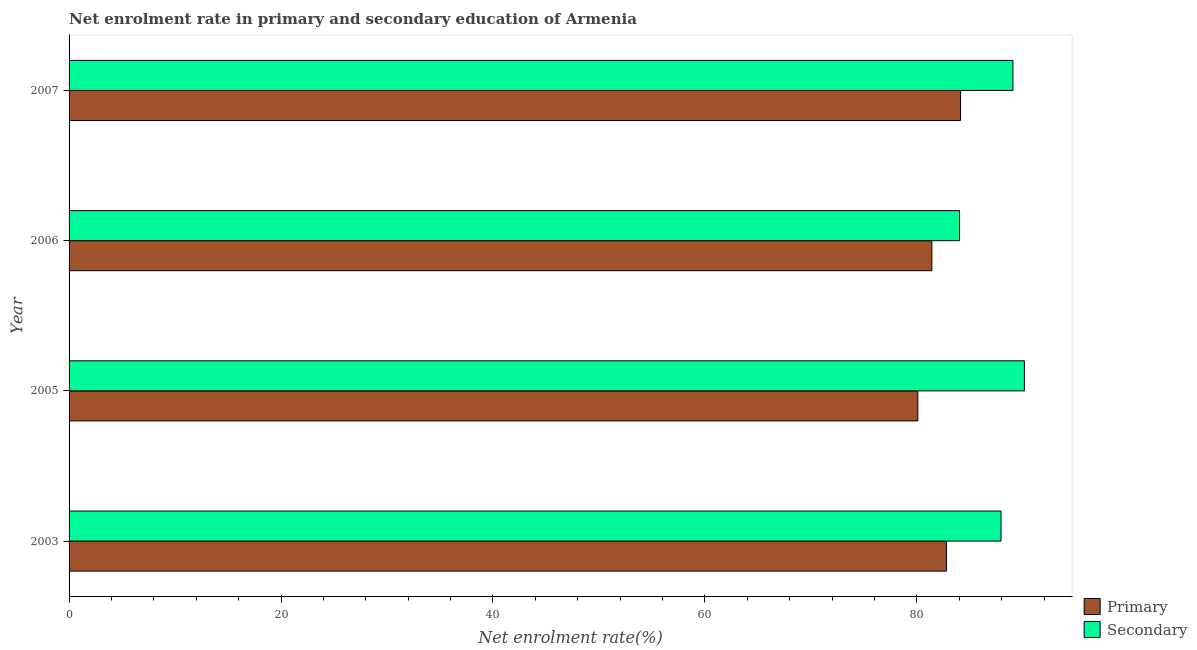How many different coloured bars are there?
Make the answer very short. 2. How many groups of bars are there?
Provide a short and direct response. 4. Are the number of bars per tick equal to the number of legend labels?
Your response must be concise. Yes. How many bars are there on the 4th tick from the top?
Give a very brief answer. 2. What is the enrollment rate in secondary education in 2005?
Your answer should be very brief. 90.14. Across all years, what is the maximum enrollment rate in primary education?
Your answer should be compact. 84.12. Across all years, what is the minimum enrollment rate in primary education?
Ensure brevity in your answer.  80.09. In which year was the enrollment rate in primary education maximum?
Make the answer very short. 2007. In which year was the enrollment rate in primary education minimum?
Offer a very short reply. 2005. What is the total enrollment rate in secondary education in the graph?
Offer a very short reply. 351.17. What is the difference between the enrollment rate in primary education in 2003 and that in 2006?
Make the answer very short. 1.38. What is the difference between the enrollment rate in primary education in 2006 and the enrollment rate in secondary education in 2007?
Provide a succinct answer. -7.65. What is the average enrollment rate in secondary education per year?
Your response must be concise. 87.79. In the year 2007, what is the difference between the enrollment rate in primary education and enrollment rate in secondary education?
Make the answer very short. -4.94. What is the ratio of the enrollment rate in secondary education in 2005 to that in 2007?
Offer a terse response. 1.01. Is the enrollment rate in secondary education in 2005 less than that in 2007?
Provide a short and direct response. No. What is the difference between the highest and the second highest enrollment rate in secondary education?
Your answer should be very brief. 1.08. What is the difference between the highest and the lowest enrollment rate in secondary education?
Your answer should be very brief. 6.12. Is the sum of the enrollment rate in secondary education in 2003 and 2005 greater than the maximum enrollment rate in primary education across all years?
Provide a succinct answer. Yes. What does the 1st bar from the top in 2007 represents?
Keep it short and to the point. Secondary. What does the 1st bar from the bottom in 2003 represents?
Offer a terse response. Primary. Are all the bars in the graph horizontal?
Provide a succinct answer. Yes. How many years are there in the graph?
Offer a very short reply. 4. What is the difference between two consecutive major ticks on the X-axis?
Give a very brief answer. 20. Are the values on the major ticks of X-axis written in scientific E-notation?
Your response must be concise. No. Does the graph contain grids?
Offer a very short reply. No. How many legend labels are there?
Your answer should be compact. 2. What is the title of the graph?
Ensure brevity in your answer.  Net enrolment rate in primary and secondary education of Armenia. Does "Nitrous oxide" appear as one of the legend labels in the graph?
Give a very brief answer. No. What is the label or title of the X-axis?
Your answer should be compact. Net enrolment rate(%). What is the Net enrolment rate(%) in Primary in 2003?
Keep it short and to the point. 82.79. What is the Net enrolment rate(%) in Secondary in 2003?
Provide a short and direct response. 87.94. What is the Net enrolment rate(%) in Primary in 2005?
Your answer should be very brief. 80.09. What is the Net enrolment rate(%) of Secondary in 2005?
Ensure brevity in your answer.  90.14. What is the Net enrolment rate(%) of Primary in 2006?
Your answer should be very brief. 81.41. What is the Net enrolment rate(%) of Secondary in 2006?
Offer a very short reply. 84.03. What is the Net enrolment rate(%) of Primary in 2007?
Your answer should be very brief. 84.12. What is the Net enrolment rate(%) in Secondary in 2007?
Provide a succinct answer. 89.06. Across all years, what is the maximum Net enrolment rate(%) in Primary?
Your answer should be very brief. 84.12. Across all years, what is the maximum Net enrolment rate(%) in Secondary?
Keep it short and to the point. 90.14. Across all years, what is the minimum Net enrolment rate(%) in Primary?
Your answer should be very brief. 80.09. Across all years, what is the minimum Net enrolment rate(%) of Secondary?
Your response must be concise. 84.03. What is the total Net enrolment rate(%) of Primary in the graph?
Your response must be concise. 328.41. What is the total Net enrolment rate(%) of Secondary in the graph?
Make the answer very short. 351.17. What is the difference between the Net enrolment rate(%) in Primary in 2003 and that in 2005?
Give a very brief answer. 2.7. What is the difference between the Net enrolment rate(%) in Secondary in 2003 and that in 2005?
Provide a short and direct response. -2.2. What is the difference between the Net enrolment rate(%) of Primary in 2003 and that in 2006?
Your answer should be very brief. 1.38. What is the difference between the Net enrolment rate(%) of Secondary in 2003 and that in 2006?
Your answer should be compact. 3.91. What is the difference between the Net enrolment rate(%) in Primary in 2003 and that in 2007?
Make the answer very short. -1.33. What is the difference between the Net enrolment rate(%) of Secondary in 2003 and that in 2007?
Your answer should be very brief. -1.12. What is the difference between the Net enrolment rate(%) in Primary in 2005 and that in 2006?
Your answer should be compact. -1.33. What is the difference between the Net enrolment rate(%) of Secondary in 2005 and that in 2006?
Your answer should be compact. 6.12. What is the difference between the Net enrolment rate(%) in Primary in 2005 and that in 2007?
Offer a very short reply. -4.03. What is the difference between the Net enrolment rate(%) in Secondary in 2005 and that in 2007?
Your response must be concise. 1.08. What is the difference between the Net enrolment rate(%) in Primary in 2006 and that in 2007?
Your response must be concise. -2.71. What is the difference between the Net enrolment rate(%) of Secondary in 2006 and that in 2007?
Your response must be concise. -5.04. What is the difference between the Net enrolment rate(%) of Primary in 2003 and the Net enrolment rate(%) of Secondary in 2005?
Your answer should be compact. -7.35. What is the difference between the Net enrolment rate(%) of Primary in 2003 and the Net enrolment rate(%) of Secondary in 2006?
Keep it short and to the point. -1.23. What is the difference between the Net enrolment rate(%) of Primary in 2003 and the Net enrolment rate(%) of Secondary in 2007?
Ensure brevity in your answer.  -6.27. What is the difference between the Net enrolment rate(%) in Primary in 2005 and the Net enrolment rate(%) in Secondary in 2006?
Give a very brief answer. -3.94. What is the difference between the Net enrolment rate(%) in Primary in 2005 and the Net enrolment rate(%) in Secondary in 2007?
Keep it short and to the point. -8.97. What is the difference between the Net enrolment rate(%) of Primary in 2006 and the Net enrolment rate(%) of Secondary in 2007?
Your answer should be very brief. -7.65. What is the average Net enrolment rate(%) in Primary per year?
Your answer should be very brief. 82.1. What is the average Net enrolment rate(%) of Secondary per year?
Provide a short and direct response. 87.79. In the year 2003, what is the difference between the Net enrolment rate(%) in Primary and Net enrolment rate(%) in Secondary?
Offer a very short reply. -5.15. In the year 2005, what is the difference between the Net enrolment rate(%) in Primary and Net enrolment rate(%) in Secondary?
Keep it short and to the point. -10.05. In the year 2006, what is the difference between the Net enrolment rate(%) in Primary and Net enrolment rate(%) in Secondary?
Offer a terse response. -2.61. In the year 2007, what is the difference between the Net enrolment rate(%) of Primary and Net enrolment rate(%) of Secondary?
Keep it short and to the point. -4.94. What is the ratio of the Net enrolment rate(%) of Primary in 2003 to that in 2005?
Give a very brief answer. 1.03. What is the ratio of the Net enrolment rate(%) in Secondary in 2003 to that in 2005?
Offer a very short reply. 0.98. What is the ratio of the Net enrolment rate(%) in Primary in 2003 to that in 2006?
Offer a very short reply. 1.02. What is the ratio of the Net enrolment rate(%) in Secondary in 2003 to that in 2006?
Your answer should be very brief. 1.05. What is the ratio of the Net enrolment rate(%) in Primary in 2003 to that in 2007?
Your answer should be compact. 0.98. What is the ratio of the Net enrolment rate(%) of Secondary in 2003 to that in 2007?
Make the answer very short. 0.99. What is the ratio of the Net enrolment rate(%) in Primary in 2005 to that in 2006?
Provide a succinct answer. 0.98. What is the ratio of the Net enrolment rate(%) in Secondary in 2005 to that in 2006?
Provide a succinct answer. 1.07. What is the ratio of the Net enrolment rate(%) in Primary in 2005 to that in 2007?
Give a very brief answer. 0.95. What is the ratio of the Net enrolment rate(%) of Secondary in 2005 to that in 2007?
Make the answer very short. 1.01. What is the ratio of the Net enrolment rate(%) of Primary in 2006 to that in 2007?
Give a very brief answer. 0.97. What is the ratio of the Net enrolment rate(%) in Secondary in 2006 to that in 2007?
Keep it short and to the point. 0.94. What is the difference between the highest and the second highest Net enrolment rate(%) in Primary?
Make the answer very short. 1.33. What is the difference between the highest and the second highest Net enrolment rate(%) of Secondary?
Offer a very short reply. 1.08. What is the difference between the highest and the lowest Net enrolment rate(%) in Primary?
Make the answer very short. 4.03. What is the difference between the highest and the lowest Net enrolment rate(%) of Secondary?
Your response must be concise. 6.12. 